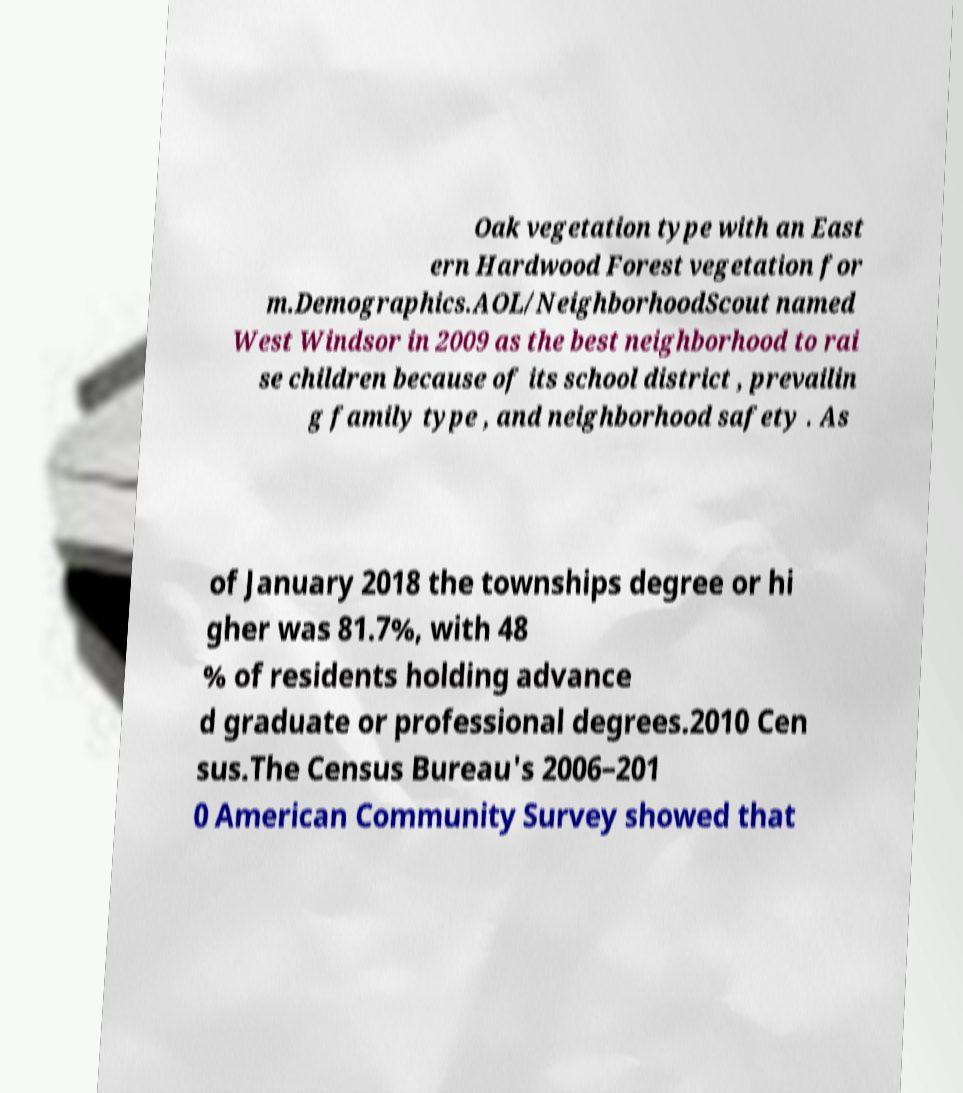I need the written content from this picture converted into text. Can you do that? Oak vegetation type with an East ern Hardwood Forest vegetation for m.Demographics.AOL/NeighborhoodScout named West Windsor in 2009 as the best neighborhood to rai se children because of its school district , prevailin g family type , and neighborhood safety . As of January 2018 the townships degree or hi gher was 81.7%, with 48 % of residents holding advance d graduate or professional degrees.2010 Cen sus.The Census Bureau's 2006–201 0 American Community Survey showed that 